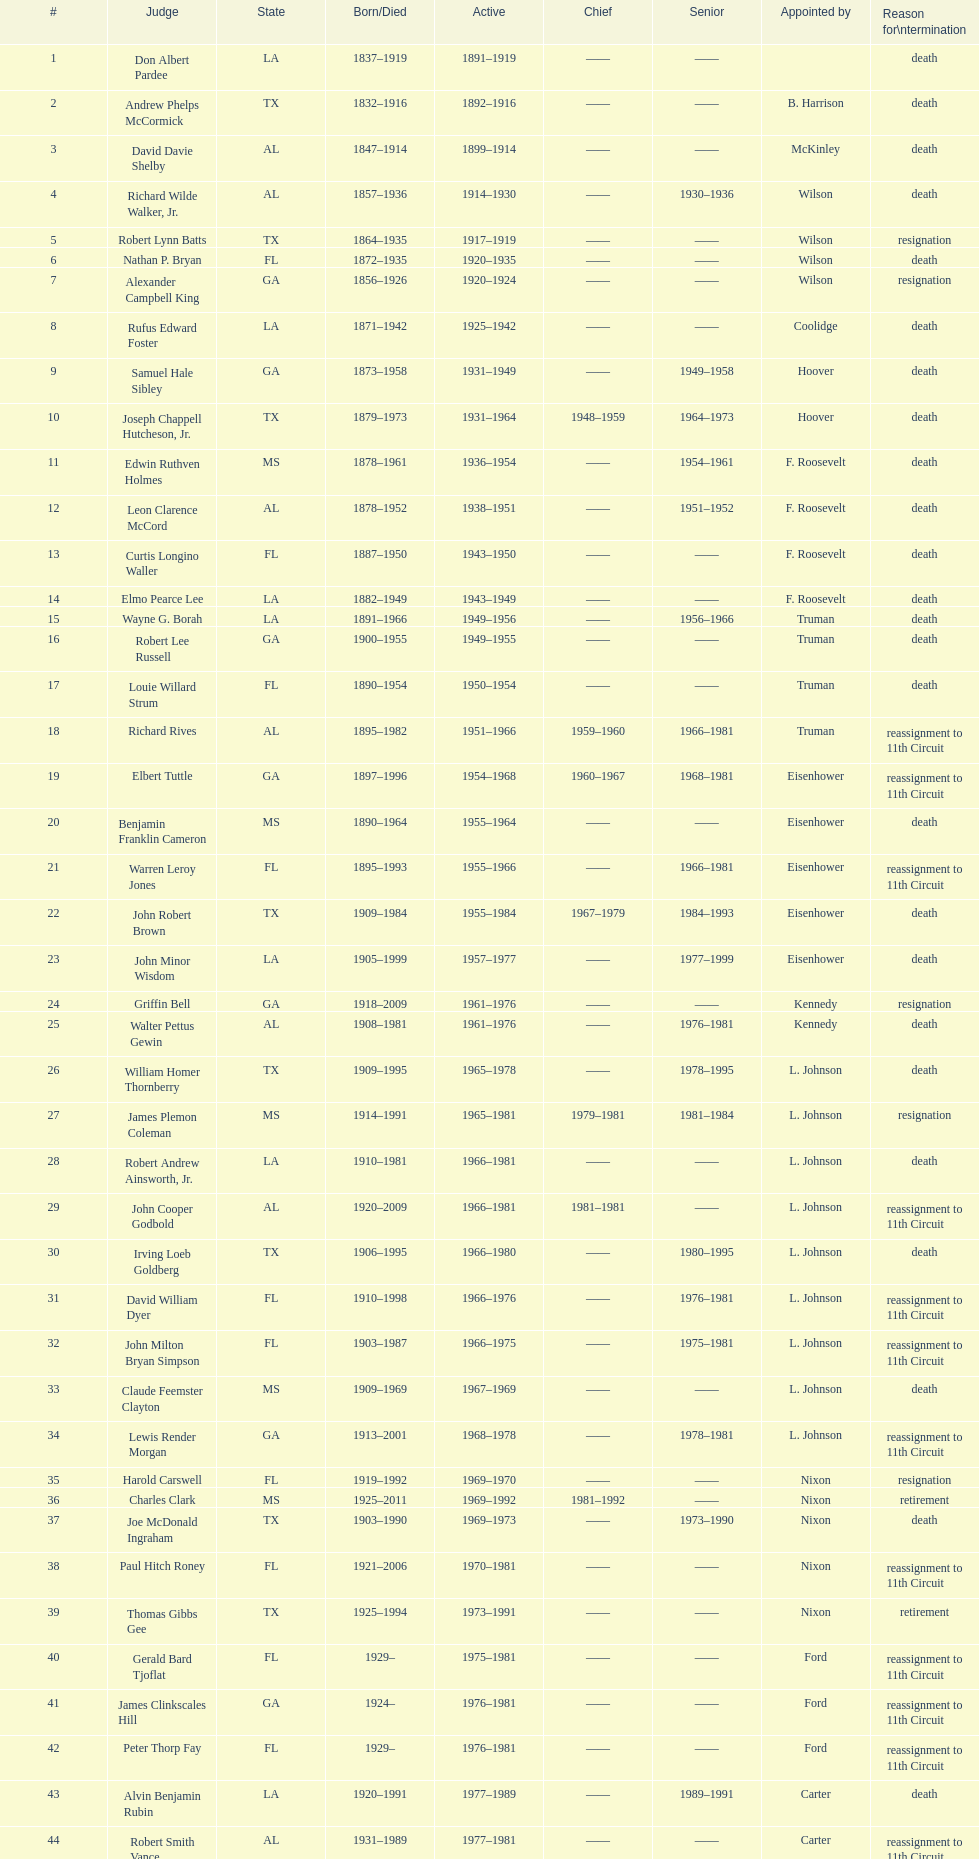Who was the sole judge nominated by mckinley? David Davie Shelby. 